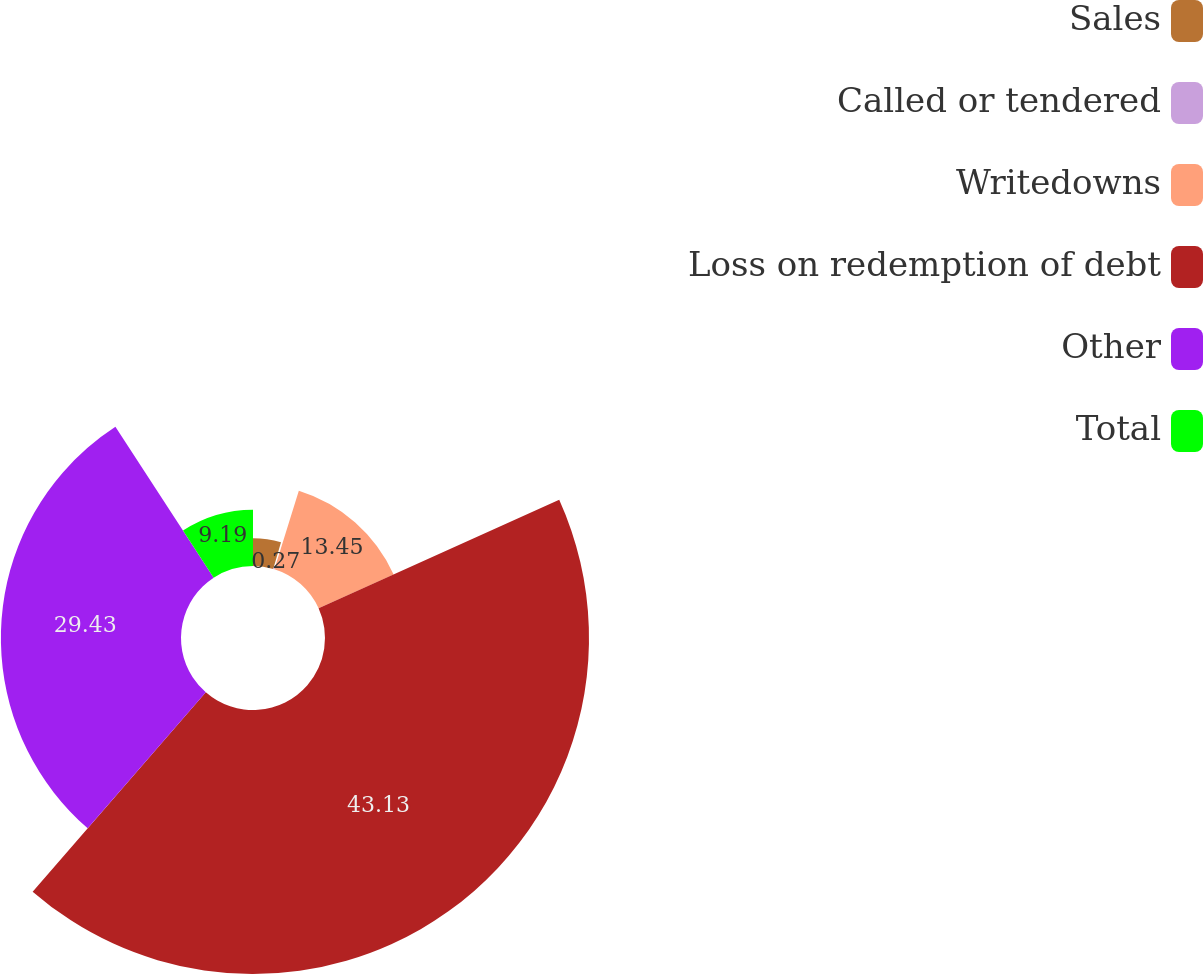<chart> <loc_0><loc_0><loc_500><loc_500><pie_chart><fcel>Sales<fcel>Called or tendered<fcel>Writedowns<fcel>Loss on redemption of debt<fcel>Other<fcel>Total<nl><fcel>4.53%<fcel>0.27%<fcel>13.45%<fcel>43.14%<fcel>29.43%<fcel>9.19%<nl></chart> 